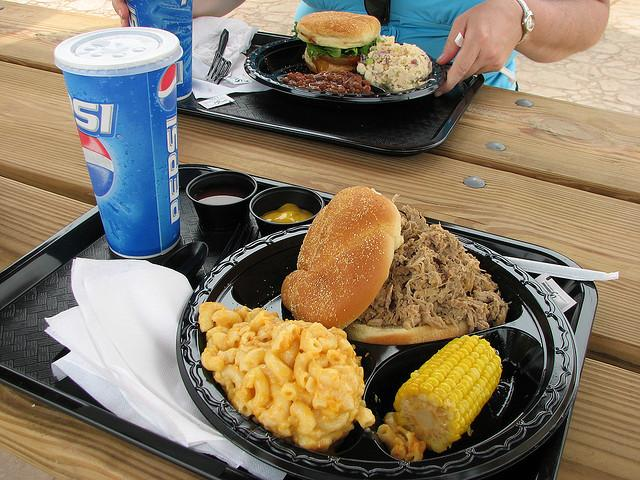Which item on the plate is highest in carbs if the person ate all of it?

Choices:
A) pork
B) corn
C) hamburger bun
D) macaroni macaroni 